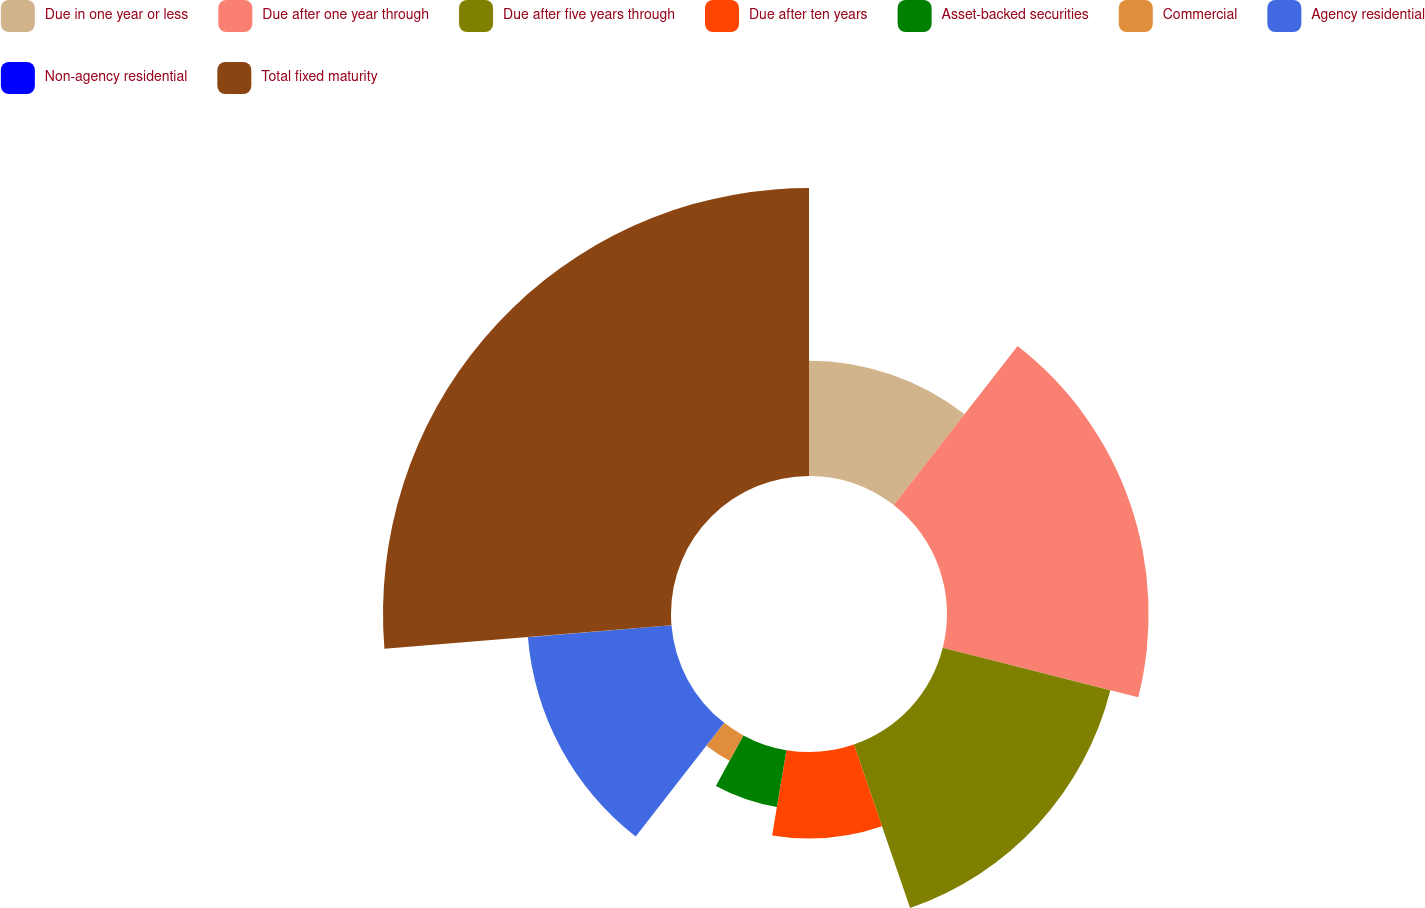<chart> <loc_0><loc_0><loc_500><loc_500><pie_chart><fcel>Due in one year or less<fcel>Due after one year through<fcel>Due after five years through<fcel>Due after ten years<fcel>Asset-backed securities<fcel>Commercial<fcel>Agency residential<fcel>Non-agency residential<fcel>Total fixed maturity<nl><fcel>10.53%<fcel>18.42%<fcel>15.79%<fcel>7.9%<fcel>5.27%<fcel>2.64%<fcel>13.16%<fcel>0.01%<fcel>26.31%<nl></chart> 